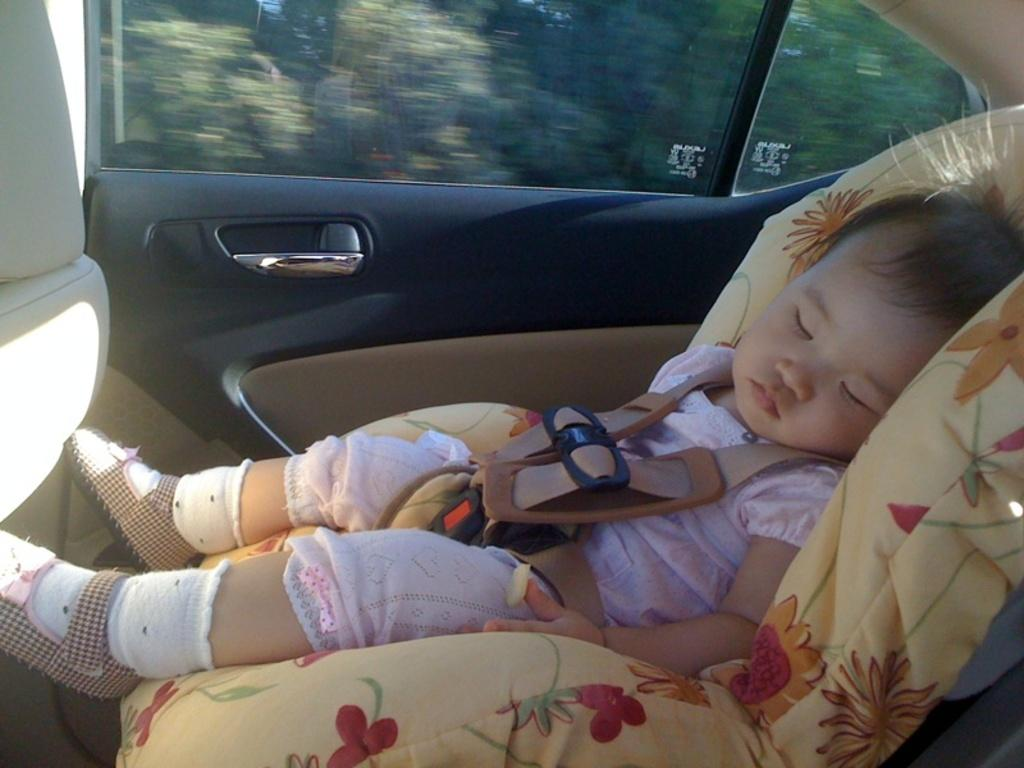What is the main subject of the image? The main subject of the image is a baby. What is the baby doing in the image? The baby is sleeping in the image. Where is the baby located? The baby is in a car. What type of brush is being used to paint the orange in the image? There is no brush or orange present in the image; it features a baby sleeping in a car. 